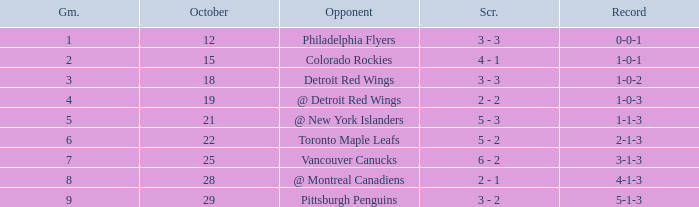Name the most october for game less than 1 None. 